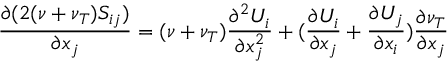<formula> <loc_0><loc_0><loc_500><loc_500>\frac { \partial ( 2 ( \nu + \nu _ { T } ) S _ { i j } ) } { \partial x _ { j } } = ( \nu + \nu _ { T } ) \frac { \partial ^ { 2 } U _ { i } } { \partial x _ { j } ^ { 2 } } + ( \frac { \partial U _ { i } } { \partial x _ { j } } + \frac { \partial U _ { j } } { \partial x _ { i } } ) \frac { \partial \nu _ { T } } { \partial x _ { j } }</formula> 